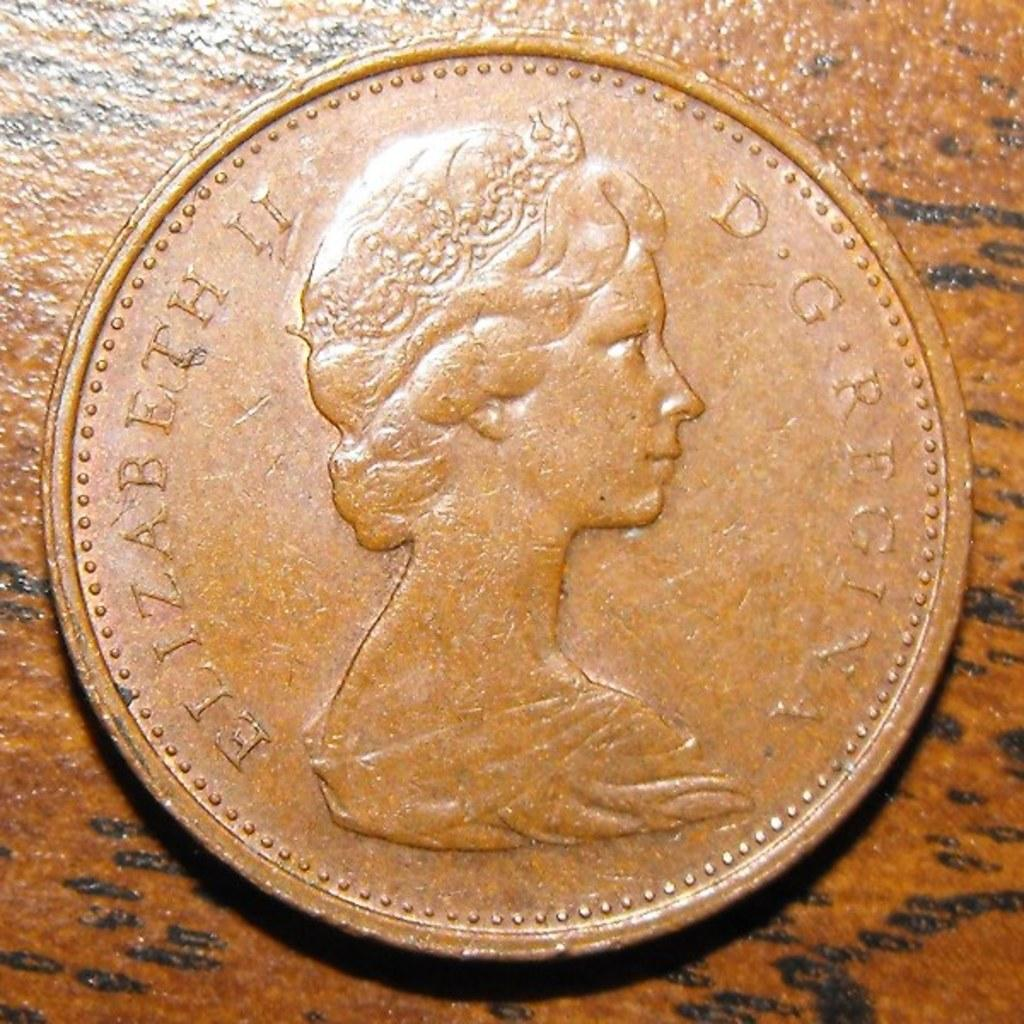What object can be seen in the image? There is a coin in the image. What type of brush is being used to develop the coin in the image? There is no brush or development process depicted in the image; it only shows a coin. 